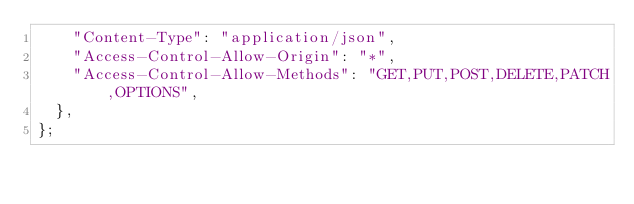<code> <loc_0><loc_0><loc_500><loc_500><_JavaScript_>    "Content-Type": "application/json",
    "Access-Control-Allow-Origin": "*",
    "Access-Control-Allow-Methods": "GET,PUT,POST,DELETE,PATCH,OPTIONS",
  },
};
</code> 